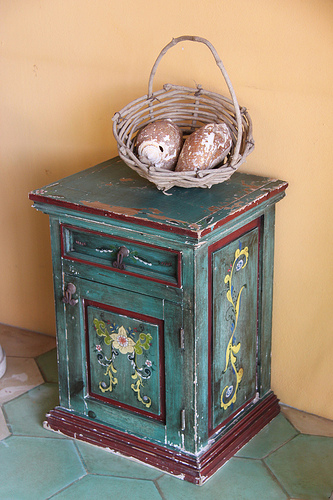<image>
Can you confirm if the basket is on the floor? No. The basket is not positioned on the floor. They may be near each other, but the basket is not supported by or resting on top of the floor. Is there a basket next to the fruit? No. The basket is not positioned next to the fruit. They are located in different areas of the scene. 